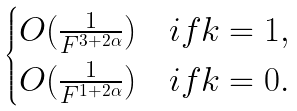Convert formula to latex. <formula><loc_0><loc_0><loc_500><loc_500>\begin{cases} O ( \frac { 1 } { F ^ { 3 + 2 \alpha } } ) & i f k = 1 , \\ O ( \frac { 1 } { F ^ { 1 + 2 \alpha } } ) & i f k = 0 . \\ \end{cases}</formula> 